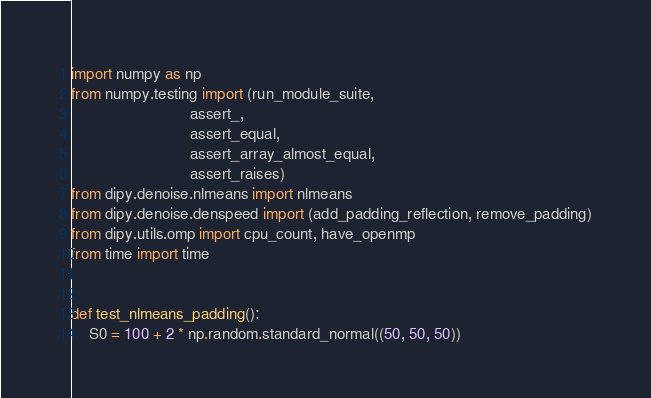<code> <loc_0><loc_0><loc_500><loc_500><_Python_>import numpy as np
from numpy.testing import (run_module_suite,
                           assert_,
                           assert_equal,
                           assert_array_almost_equal,
                           assert_raises)
from dipy.denoise.nlmeans import nlmeans
from dipy.denoise.denspeed import (add_padding_reflection, remove_padding)
from dipy.utils.omp import cpu_count, have_openmp
from time import time


def test_nlmeans_padding():
    S0 = 100 + 2 * np.random.standard_normal((50, 50, 50))</code> 